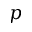Convert formula to latex. <formula><loc_0><loc_0><loc_500><loc_500>p</formula> 